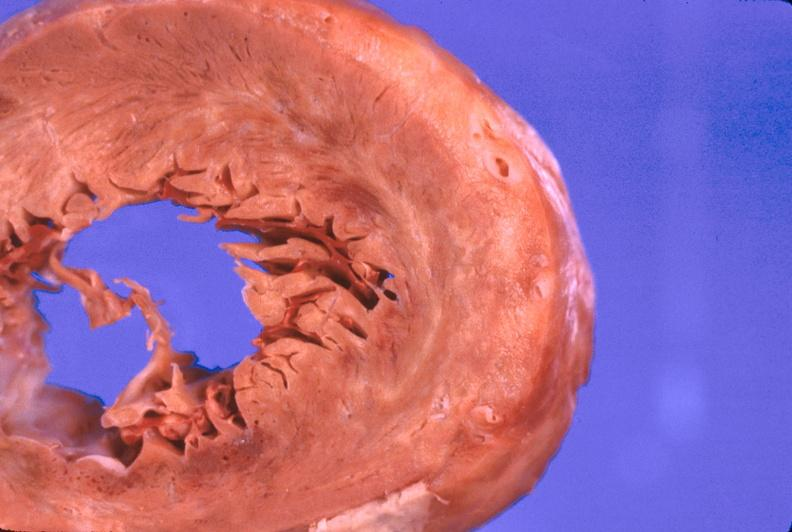where is this?
Answer the question using a single word or phrase. Heart 